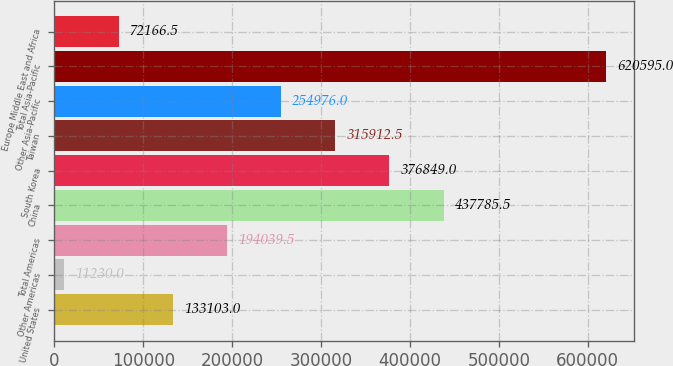<chart> <loc_0><loc_0><loc_500><loc_500><bar_chart><fcel>United States<fcel>Other Americas<fcel>Total Americas<fcel>China<fcel>South Korea<fcel>Taiwan<fcel>Other Asia-Pacific<fcel>Total Asia-Pacific<fcel>Europe Middle East and Africa<nl><fcel>133103<fcel>11230<fcel>194040<fcel>437786<fcel>376849<fcel>315912<fcel>254976<fcel>620595<fcel>72166.5<nl></chart> 